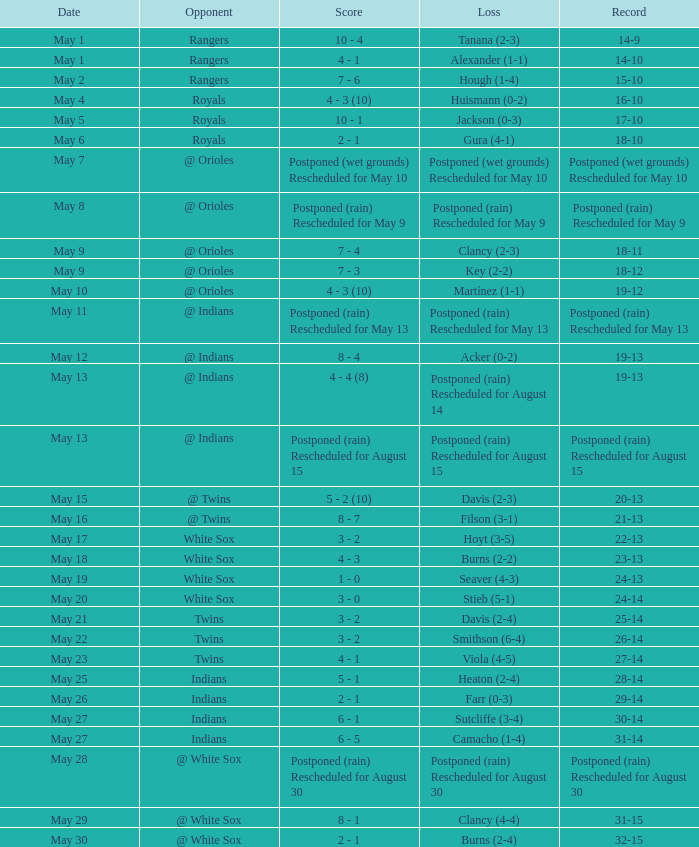What was the deficit of the match when the score was 21-13? Filson (3-1). I'm looking to parse the entire table for insights. Could you assist me with that? {'header': ['Date', 'Opponent', 'Score', 'Loss', 'Record'], 'rows': [['May 1', 'Rangers', '10 - 4', 'Tanana (2-3)', '14-9'], ['May 1', 'Rangers', '4 - 1', 'Alexander (1-1)', '14-10'], ['May 2', 'Rangers', '7 - 6', 'Hough (1-4)', '15-10'], ['May 4', 'Royals', '4 - 3 (10)', 'Huismann (0-2)', '16-10'], ['May 5', 'Royals', '10 - 1', 'Jackson (0-3)', '17-10'], ['May 6', 'Royals', '2 - 1', 'Gura (4-1)', '18-10'], ['May 7', '@ Orioles', 'Postponed (wet grounds) Rescheduled for May 10', 'Postponed (wet grounds) Rescheduled for May 10', 'Postponed (wet grounds) Rescheduled for May 10'], ['May 8', '@ Orioles', 'Postponed (rain) Rescheduled for May 9', 'Postponed (rain) Rescheduled for May 9', 'Postponed (rain) Rescheduled for May 9'], ['May 9', '@ Orioles', '7 - 4', 'Clancy (2-3)', '18-11'], ['May 9', '@ Orioles', '7 - 3', 'Key (2-2)', '18-12'], ['May 10', '@ Orioles', '4 - 3 (10)', 'Martínez (1-1)', '19-12'], ['May 11', '@ Indians', 'Postponed (rain) Rescheduled for May 13', 'Postponed (rain) Rescheduled for May 13', 'Postponed (rain) Rescheduled for May 13'], ['May 12', '@ Indians', '8 - 4', 'Acker (0-2)', '19-13'], ['May 13', '@ Indians', '4 - 4 (8)', 'Postponed (rain) Rescheduled for August 14', '19-13'], ['May 13', '@ Indians', 'Postponed (rain) Rescheduled for August 15', 'Postponed (rain) Rescheduled for August 15', 'Postponed (rain) Rescheduled for August 15'], ['May 15', '@ Twins', '5 - 2 (10)', 'Davis (2-3)', '20-13'], ['May 16', '@ Twins', '8 - 7', 'Filson (3-1)', '21-13'], ['May 17', 'White Sox', '3 - 2', 'Hoyt (3-5)', '22-13'], ['May 18', 'White Sox', '4 - 3', 'Burns (2-2)', '23-13'], ['May 19', 'White Sox', '1 - 0', 'Seaver (4-3)', '24-13'], ['May 20', 'White Sox', '3 - 0', 'Stieb (5-1)', '24-14'], ['May 21', 'Twins', '3 - 2', 'Davis (2-4)', '25-14'], ['May 22', 'Twins', '3 - 2', 'Smithson (6-4)', '26-14'], ['May 23', 'Twins', '4 - 1', 'Viola (4-5)', '27-14'], ['May 25', 'Indians', '5 - 1', 'Heaton (2-4)', '28-14'], ['May 26', 'Indians', '2 - 1', 'Farr (0-3)', '29-14'], ['May 27', 'Indians', '6 - 1', 'Sutcliffe (3-4)', '30-14'], ['May 27', 'Indians', '6 - 5', 'Camacho (1-4)', '31-14'], ['May 28', '@ White Sox', 'Postponed (rain) Rescheduled for August 30', 'Postponed (rain) Rescheduled for August 30', 'Postponed (rain) Rescheduled for August 30'], ['May 29', '@ White Sox', '8 - 1', 'Clancy (4-4)', '31-15'], ['May 30', '@ White Sox', '2 - 1', 'Burns (2-4)', '32-15']]} 